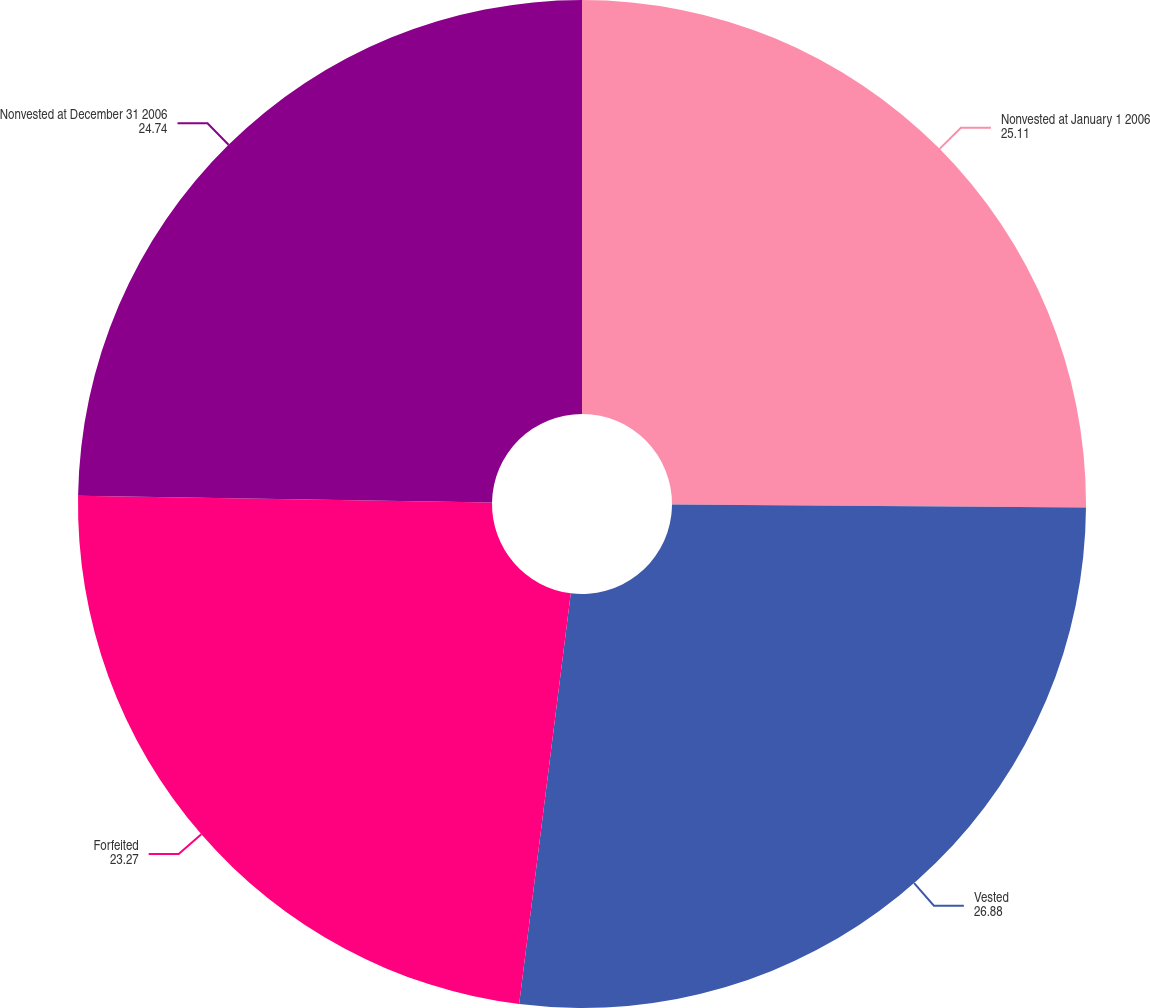Convert chart. <chart><loc_0><loc_0><loc_500><loc_500><pie_chart><fcel>Nonvested at January 1 2006<fcel>Vested<fcel>Forfeited<fcel>Nonvested at December 31 2006<nl><fcel>25.11%<fcel>26.88%<fcel>23.27%<fcel>24.74%<nl></chart> 